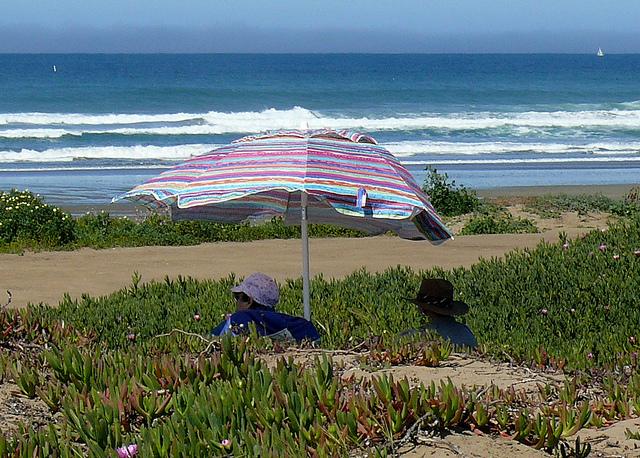What colors are the umbrella?
Short answer required. Rainbow. How many people are sitting under the umbrella?
Answer briefly. 2. What are the people under?
Short answer required. Umbrella. 